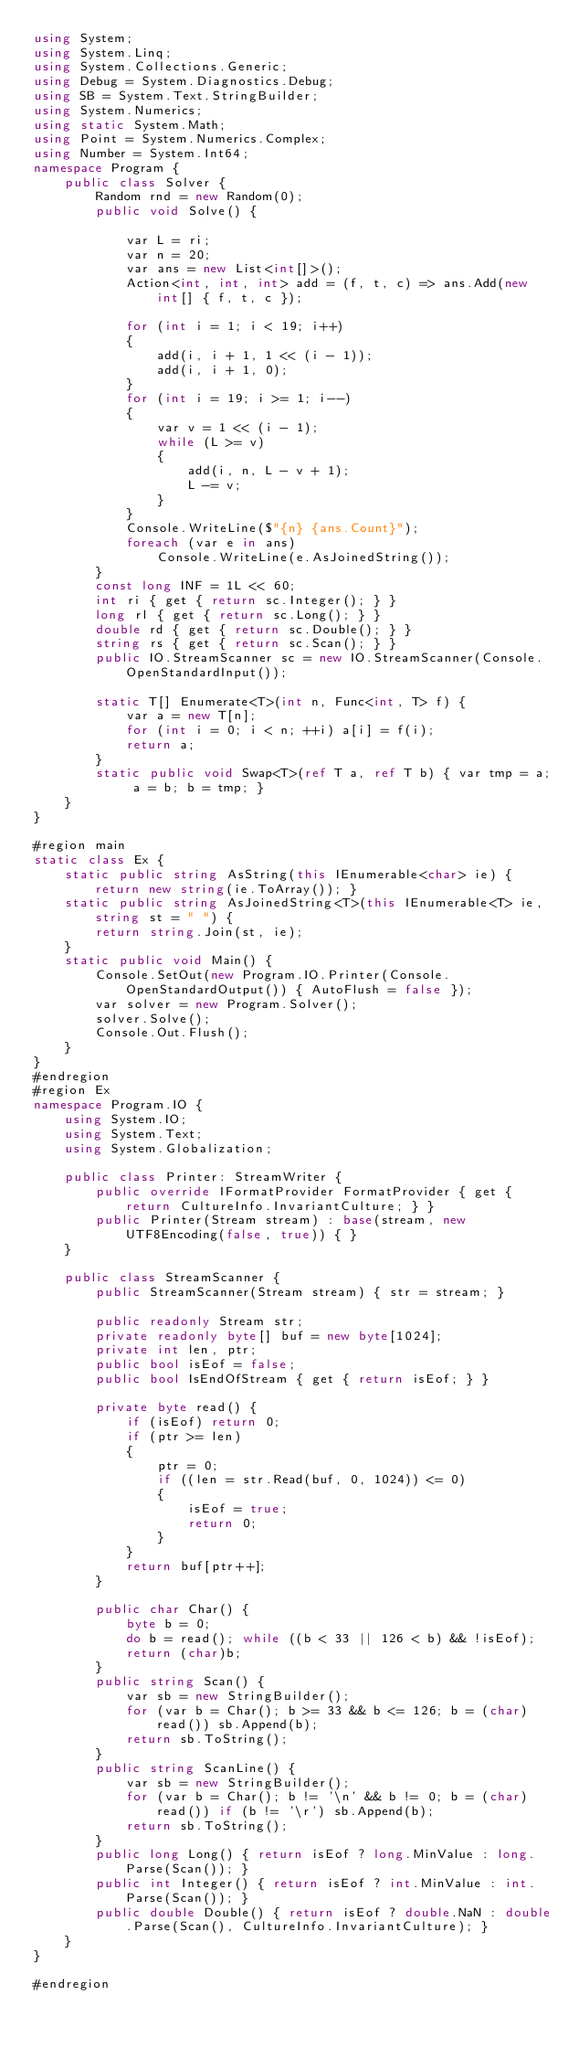Convert code to text. <code><loc_0><loc_0><loc_500><loc_500><_C#_>using System;
using System.Linq;
using System.Collections.Generic;
using Debug = System.Diagnostics.Debug;
using SB = System.Text.StringBuilder;
using System.Numerics;
using static System.Math;
using Point = System.Numerics.Complex;
using Number = System.Int64;
namespace Program {
    public class Solver {
        Random rnd = new Random(0);
        public void Solve() {

            var L = ri;
            var n = 20;
            var ans = new List<int[]>();
            Action<int, int, int> add = (f, t, c) => ans.Add(new int[] { f, t, c });

            for (int i = 1; i < 19; i++)
            {
                add(i, i + 1, 1 << (i - 1));
                add(i, i + 1, 0);
            }
            for (int i = 19; i >= 1; i--)
            {
                var v = 1 << (i - 1);
                while (L >= v)
                {
                    add(i, n, L - v + 1);
                    L -= v;
                }
            }
            Console.WriteLine($"{n} {ans.Count}");
            foreach (var e in ans)
                Console.WriteLine(e.AsJoinedString());
        }
        const long INF = 1L << 60;
        int ri { get { return sc.Integer(); } }
        long rl { get { return sc.Long(); } }
        double rd { get { return sc.Double(); } }
        string rs { get { return sc.Scan(); } }
        public IO.StreamScanner sc = new IO.StreamScanner(Console.OpenStandardInput());

        static T[] Enumerate<T>(int n, Func<int, T> f) {
            var a = new T[n];
            for (int i = 0; i < n; ++i) a[i] = f(i);
            return a;
        }
        static public void Swap<T>(ref T a, ref T b) { var tmp = a; a = b; b = tmp; }
    }
}

#region main
static class Ex {
    static public string AsString(this IEnumerable<char> ie) { return new string(ie.ToArray()); }
    static public string AsJoinedString<T>(this IEnumerable<T> ie, string st = " ") {
        return string.Join(st, ie);
    }
    static public void Main() {
        Console.SetOut(new Program.IO.Printer(Console.OpenStandardOutput()) { AutoFlush = false });
        var solver = new Program.Solver();
        solver.Solve();
        Console.Out.Flush();
    }
}
#endregion
#region Ex
namespace Program.IO {
    using System.IO;
    using System.Text;
    using System.Globalization;

    public class Printer: StreamWriter {
        public override IFormatProvider FormatProvider { get { return CultureInfo.InvariantCulture; } }
        public Printer(Stream stream) : base(stream, new UTF8Encoding(false, true)) { }
    }

    public class StreamScanner {
        public StreamScanner(Stream stream) { str = stream; }

        public readonly Stream str;
        private readonly byte[] buf = new byte[1024];
        private int len, ptr;
        public bool isEof = false;
        public bool IsEndOfStream { get { return isEof; } }

        private byte read() {
            if (isEof) return 0;
            if (ptr >= len)
            {
                ptr = 0;
                if ((len = str.Read(buf, 0, 1024)) <= 0)
                {
                    isEof = true;
                    return 0;
                }
            }
            return buf[ptr++];
        }

        public char Char() {
            byte b = 0;
            do b = read(); while ((b < 33 || 126 < b) && !isEof);
            return (char)b;
        }
        public string Scan() {
            var sb = new StringBuilder();
            for (var b = Char(); b >= 33 && b <= 126; b = (char)read()) sb.Append(b);
            return sb.ToString();
        }
        public string ScanLine() {
            var sb = new StringBuilder();
            for (var b = Char(); b != '\n' && b != 0; b = (char)read()) if (b != '\r') sb.Append(b);
            return sb.ToString();
        }
        public long Long() { return isEof ? long.MinValue : long.Parse(Scan()); }
        public int Integer() { return isEof ? int.MinValue : int.Parse(Scan()); }
        public double Double() { return isEof ? double.NaN : double.Parse(Scan(), CultureInfo.InvariantCulture); }
    }
}

#endregion

</code> 